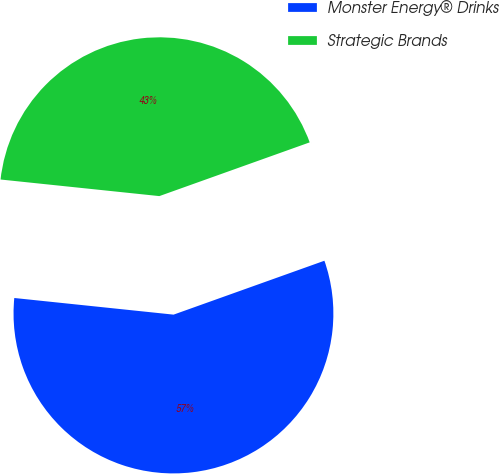Convert chart. <chart><loc_0><loc_0><loc_500><loc_500><pie_chart><fcel>Monster Energy® Drinks<fcel>Strategic Brands<nl><fcel>57.12%<fcel>42.88%<nl></chart> 